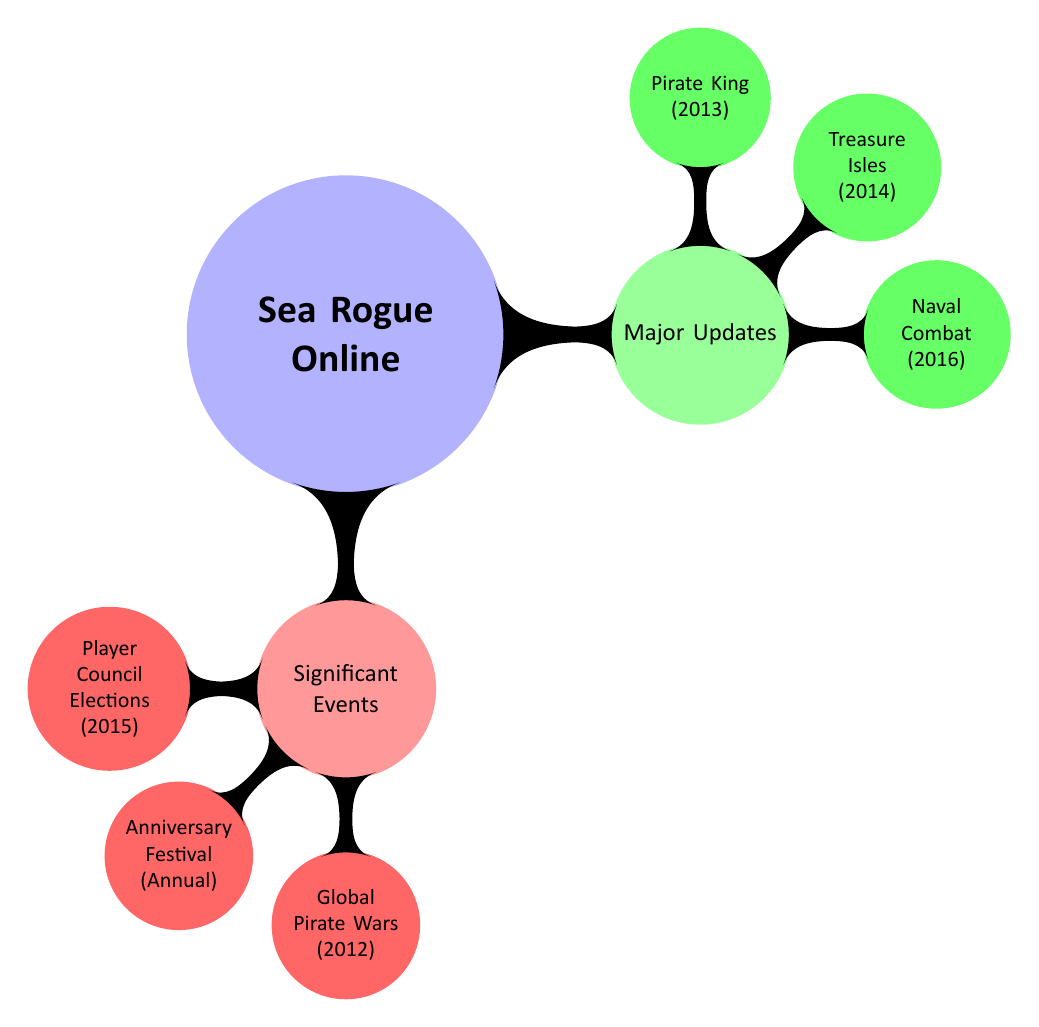What update introduced new pirate classes? The diagram shows that "Pirate King" is a major update, which is explicitly labeled to have introduced new pirate classes. Therefore, the answer is the name of that update.
Answer: Pirate King When was the Treasure Isles Expansion released? The diagram indicates that the "Treasure Isles" update occurred in the year 2014, and it is directly associated with that year. Hence, the answer is the year of its release.
Answer: 2014 What annual event takes place on March 10? The diagram clearly indicates the "Anniversary Festival" occurs every year on March 10. Therefore, the event specifically named in the question can be directly taken from the diagram.
Answer: Anniversary Festival How many major updates are listed? The diagram shows three distinct updates under the "Major Updates" section. This means that to find the answer, simply count the number of updates shown.
Answer: 3 Which event allowed community elections? The diagram includes "Player Council Elections" as the event related to community elections, making it easy to directly reference that event from the diagram.
Answer: Player Council Elections What significant event occurred worldwide on June 20, 2012? The diagram indicates that the "Global Pirate Wars" is the significant event that is dated to June 20, 2012. Thus, we refer directly to this specific event shown in the diagram.
Answer: Global Pirate Wars Which update occurred before the Naval Combat Overhaul? According to the diagram, "Treasure Isles" comes before the "Naval Combat Overhaul" when considering the chronological order of years, indicating the reasoning is based on their placement in time.
Answer: Treasure Isles What type of events occur annually in the game? The diagram specifies that the "Anniversary Festival" occurs annually, which directly identifies the type of events that are repeated every year.
Answer: Annual events How many significant events are mentioned? By counting the items displayed under "Significant Events" in the diagram, which lists three distinct entries, we reach the answer.
Answer: 3 